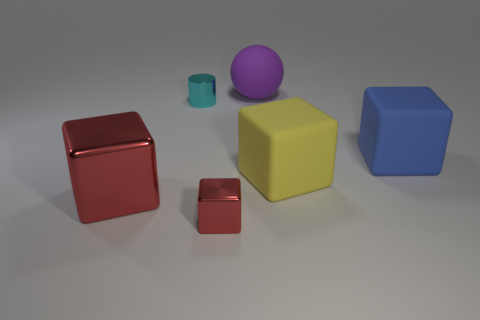Subtract all small metal blocks. How many blocks are left? 3 Subtract all blue cubes. How many cubes are left? 3 Subtract all blocks. How many objects are left? 2 Add 1 cyan things. How many objects exist? 7 Subtract 1 balls. How many balls are left? 0 Subtract 0 brown blocks. How many objects are left? 6 Subtract all cyan blocks. Subtract all purple cylinders. How many blocks are left? 4 Subtract all brown cylinders. How many blue blocks are left? 1 Subtract all tiny blue cylinders. Subtract all blue cubes. How many objects are left? 5 Add 5 purple spheres. How many purple spheres are left? 6 